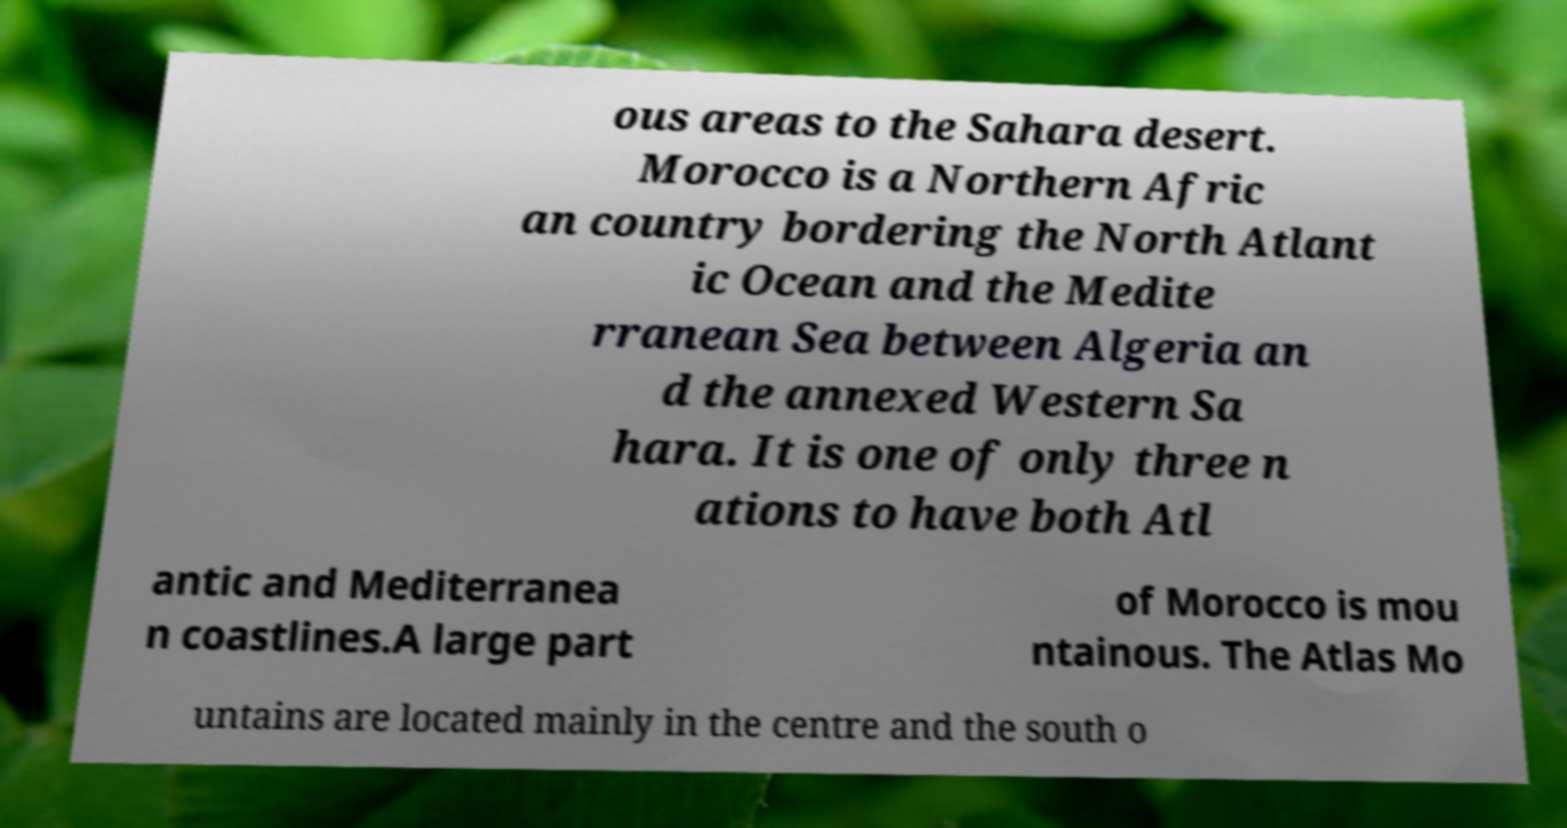I need the written content from this picture converted into text. Can you do that? ous areas to the Sahara desert. Morocco is a Northern Afric an country bordering the North Atlant ic Ocean and the Medite rranean Sea between Algeria an d the annexed Western Sa hara. It is one of only three n ations to have both Atl antic and Mediterranea n coastlines.A large part of Morocco is mou ntainous. The Atlas Mo untains are located mainly in the centre and the south o 